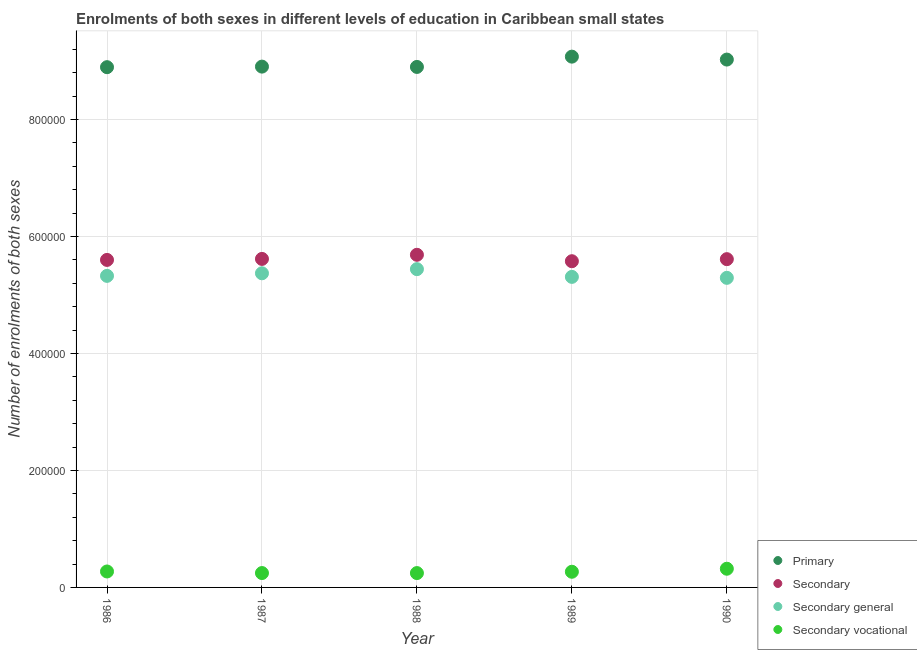What is the number of enrolments in secondary general education in 1990?
Your answer should be compact. 5.29e+05. Across all years, what is the maximum number of enrolments in secondary general education?
Give a very brief answer. 5.44e+05. Across all years, what is the minimum number of enrolments in secondary vocational education?
Ensure brevity in your answer.  2.45e+04. In which year was the number of enrolments in primary education maximum?
Provide a succinct answer. 1989. What is the total number of enrolments in secondary education in the graph?
Offer a very short reply. 2.81e+06. What is the difference between the number of enrolments in primary education in 1986 and that in 1988?
Ensure brevity in your answer.  -413.75. What is the difference between the number of enrolments in secondary vocational education in 1988 and the number of enrolments in primary education in 1990?
Give a very brief answer. -8.78e+05. What is the average number of enrolments in primary education per year?
Your answer should be compact. 8.96e+05. In the year 1987, what is the difference between the number of enrolments in secondary vocational education and number of enrolments in secondary general education?
Ensure brevity in your answer.  -5.13e+05. What is the ratio of the number of enrolments in secondary vocational education in 1986 to that in 1987?
Provide a succinct answer. 1.11. What is the difference between the highest and the second highest number of enrolments in secondary vocational education?
Offer a very short reply. 4682.17. What is the difference between the highest and the lowest number of enrolments in secondary vocational education?
Make the answer very short. 7419.81. Is it the case that in every year, the sum of the number of enrolments in primary education and number of enrolments in secondary education is greater than the sum of number of enrolments in secondary vocational education and number of enrolments in secondary general education?
Make the answer very short. Yes. Is it the case that in every year, the sum of the number of enrolments in primary education and number of enrolments in secondary education is greater than the number of enrolments in secondary general education?
Provide a succinct answer. Yes. Is the number of enrolments in secondary general education strictly greater than the number of enrolments in primary education over the years?
Your answer should be compact. No. Is the number of enrolments in primary education strictly less than the number of enrolments in secondary vocational education over the years?
Ensure brevity in your answer.  No. How many years are there in the graph?
Make the answer very short. 5. Does the graph contain any zero values?
Keep it short and to the point. No. How many legend labels are there?
Keep it short and to the point. 4. What is the title of the graph?
Your answer should be compact. Enrolments of both sexes in different levels of education in Caribbean small states. What is the label or title of the X-axis?
Make the answer very short. Year. What is the label or title of the Y-axis?
Provide a short and direct response. Number of enrolments of both sexes. What is the Number of enrolments of both sexes of Primary in 1986?
Offer a very short reply. 8.89e+05. What is the Number of enrolments of both sexes in Secondary in 1986?
Give a very brief answer. 5.60e+05. What is the Number of enrolments of both sexes in Secondary general in 1986?
Keep it short and to the point. 5.33e+05. What is the Number of enrolments of both sexes of Secondary vocational in 1986?
Provide a succinct answer. 2.73e+04. What is the Number of enrolments of both sexes in Primary in 1987?
Your answer should be very brief. 8.90e+05. What is the Number of enrolments of both sexes of Secondary in 1987?
Give a very brief answer. 5.62e+05. What is the Number of enrolments of both sexes in Secondary general in 1987?
Provide a succinct answer. 5.37e+05. What is the Number of enrolments of both sexes in Secondary vocational in 1987?
Offer a very short reply. 2.46e+04. What is the Number of enrolments of both sexes of Primary in 1988?
Your response must be concise. 8.90e+05. What is the Number of enrolments of both sexes of Secondary in 1988?
Provide a succinct answer. 5.69e+05. What is the Number of enrolments of both sexes in Secondary general in 1988?
Offer a terse response. 5.44e+05. What is the Number of enrolments of both sexes of Secondary vocational in 1988?
Provide a short and direct response. 2.45e+04. What is the Number of enrolments of both sexes in Primary in 1989?
Make the answer very short. 9.07e+05. What is the Number of enrolments of both sexes of Secondary in 1989?
Keep it short and to the point. 5.58e+05. What is the Number of enrolments of both sexes of Secondary general in 1989?
Provide a succinct answer. 5.31e+05. What is the Number of enrolments of both sexes of Secondary vocational in 1989?
Your response must be concise. 2.68e+04. What is the Number of enrolments of both sexes in Primary in 1990?
Provide a short and direct response. 9.02e+05. What is the Number of enrolments of both sexes in Secondary in 1990?
Provide a succinct answer. 5.61e+05. What is the Number of enrolments of both sexes in Secondary general in 1990?
Offer a terse response. 5.29e+05. What is the Number of enrolments of both sexes of Secondary vocational in 1990?
Your answer should be compact. 3.20e+04. Across all years, what is the maximum Number of enrolments of both sexes in Primary?
Offer a very short reply. 9.07e+05. Across all years, what is the maximum Number of enrolments of both sexes of Secondary?
Give a very brief answer. 5.69e+05. Across all years, what is the maximum Number of enrolments of both sexes in Secondary general?
Make the answer very short. 5.44e+05. Across all years, what is the maximum Number of enrolments of both sexes in Secondary vocational?
Make the answer very short. 3.20e+04. Across all years, what is the minimum Number of enrolments of both sexes of Primary?
Keep it short and to the point. 8.89e+05. Across all years, what is the minimum Number of enrolments of both sexes in Secondary?
Give a very brief answer. 5.58e+05. Across all years, what is the minimum Number of enrolments of both sexes in Secondary general?
Offer a very short reply. 5.29e+05. Across all years, what is the minimum Number of enrolments of both sexes of Secondary vocational?
Provide a succinct answer. 2.45e+04. What is the total Number of enrolments of both sexes in Primary in the graph?
Keep it short and to the point. 4.48e+06. What is the total Number of enrolments of both sexes in Secondary in the graph?
Ensure brevity in your answer.  2.81e+06. What is the total Number of enrolments of both sexes in Secondary general in the graph?
Keep it short and to the point. 2.67e+06. What is the total Number of enrolments of both sexes in Secondary vocational in the graph?
Your response must be concise. 1.35e+05. What is the difference between the Number of enrolments of both sexes in Primary in 1986 and that in 1987?
Keep it short and to the point. -958.44. What is the difference between the Number of enrolments of both sexes of Secondary in 1986 and that in 1987?
Make the answer very short. -1705.69. What is the difference between the Number of enrolments of both sexes of Secondary general in 1986 and that in 1987?
Offer a terse response. -4404.25. What is the difference between the Number of enrolments of both sexes in Secondary vocational in 1986 and that in 1987?
Offer a terse response. 2698.62. What is the difference between the Number of enrolments of both sexes of Primary in 1986 and that in 1988?
Your response must be concise. -413.75. What is the difference between the Number of enrolments of both sexes in Secondary in 1986 and that in 1988?
Make the answer very short. -8743. What is the difference between the Number of enrolments of both sexes in Secondary general in 1986 and that in 1988?
Offer a terse response. -1.15e+04. What is the difference between the Number of enrolments of both sexes of Secondary vocational in 1986 and that in 1988?
Offer a very short reply. 2737.64. What is the difference between the Number of enrolments of both sexes in Primary in 1986 and that in 1989?
Make the answer very short. -1.80e+04. What is the difference between the Number of enrolments of both sexes of Secondary in 1986 and that in 1989?
Your answer should be very brief. 2220.38. What is the difference between the Number of enrolments of both sexes in Secondary general in 1986 and that in 1989?
Your answer should be very brief. 1734.56. What is the difference between the Number of enrolments of both sexes in Secondary vocational in 1986 and that in 1989?
Offer a terse response. 485.85. What is the difference between the Number of enrolments of both sexes of Primary in 1986 and that in 1990?
Offer a very short reply. -1.30e+04. What is the difference between the Number of enrolments of both sexes of Secondary in 1986 and that in 1990?
Give a very brief answer. -1305.38. What is the difference between the Number of enrolments of both sexes of Secondary general in 1986 and that in 1990?
Your answer should be very brief. 3376.81. What is the difference between the Number of enrolments of both sexes in Secondary vocational in 1986 and that in 1990?
Make the answer very short. -4682.17. What is the difference between the Number of enrolments of both sexes of Primary in 1987 and that in 1988?
Provide a short and direct response. 544.69. What is the difference between the Number of enrolments of both sexes in Secondary in 1987 and that in 1988?
Offer a very short reply. -7037.31. What is the difference between the Number of enrolments of both sexes of Secondary general in 1987 and that in 1988?
Keep it short and to the point. -7076.38. What is the difference between the Number of enrolments of both sexes of Secondary vocational in 1987 and that in 1988?
Your response must be concise. 39.03. What is the difference between the Number of enrolments of both sexes in Primary in 1987 and that in 1989?
Provide a succinct answer. -1.70e+04. What is the difference between the Number of enrolments of both sexes of Secondary in 1987 and that in 1989?
Provide a short and direct response. 3926.06. What is the difference between the Number of enrolments of both sexes of Secondary general in 1987 and that in 1989?
Offer a very short reply. 6138.81. What is the difference between the Number of enrolments of both sexes in Secondary vocational in 1987 and that in 1989?
Keep it short and to the point. -2212.77. What is the difference between the Number of enrolments of both sexes of Primary in 1987 and that in 1990?
Provide a succinct answer. -1.20e+04. What is the difference between the Number of enrolments of both sexes in Secondary in 1987 and that in 1990?
Your answer should be very brief. 400.31. What is the difference between the Number of enrolments of both sexes in Secondary general in 1987 and that in 1990?
Offer a terse response. 7781.06. What is the difference between the Number of enrolments of both sexes of Secondary vocational in 1987 and that in 1990?
Your answer should be compact. -7380.79. What is the difference between the Number of enrolments of both sexes in Primary in 1988 and that in 1989?
Your response must be concise. -1.76e+04. What is the difference between the Number of enrolments of both sexes in Secondary in 1988 and that in 1989?
Provide a short and direct response. 1.10e+04. What is the difference between the Number of enrolments of both sexes of Secondary general in 1988 and that in 1989?
Offer a very short reply. 1.32e+04. What is the difference between the Number of enrolments of both sexes of Secondary vocational in 1988 and that in 1989?
Your answer should be compact. -2251.79. What is the difference between the Number of enrolments of both sexes in Primary in 1988 and that in 1990?
Provide a short and direct response. -1.26e+04. What is the difference between the Number of enrolments of both sexes in Secondary in 1988 and that in 1990?
Make the answer very short. 7437.62. What is the difference between the Number of enrolments of both sexes in Secondary general in 1988 and that in 1990?
Provide a succinct answer. 1.49e+04. What is the difference between the Number of enrolments of both sexes of Secondary vocational in 1988 and that in 1990?
Your response must be concise. -7419.81. What is the difference between the Number of enrolments of both sexes of Primary in 1989 and that in 1990?
Give a very brief answer. 5000.31. What is the difference between the Number of enrolments of both sexes in Secondary in 1989 and that in 1990?
Give a very brief answer. -3525.75. What is the difference between the Number of enrolments of both sexes of Secondary general in 1989 and that in 1990?
Give a very brief answer. 1642.25. What is the difference between the Number of enrolments of both sexes of Secondary vocational in 1989 and that in 1990?
Offer a terse response. -5168.02. What is the difference between the Number of enrolments of both sexes of Primary in 1986 and the Number of enrolments of both sexes of Secondary in 1987?
Ensure brevity in your answer.  3.28e+05. What is the difference between the Number of enrolments of both sexes of Primary in 1986 and the Number of enrolments of both sexes of Secondary general in 1987?
Offer a terse response. 3.52e+05. What is the difference between the Number of enrolments of both sexes of Primary in 1986 and the Number of enrolments of both sexes of Secondary vocational in 1987?
Offer a terse response. 8.65e+05. What is the difference between the Number of enrolments of both sexes in Secondary in 1986 and the Number of enrolments of both sexes in Secondary general in 1987?
Offer a very short reply. 2.29e+04. What is the difference between the Number of enrolments of both sexes of Secondary in 1986 and the Number of enrolments of both sexes of Secondary vocational in 1987?
Your answer should be very brief. 5.35e+05. What is the difference between the Number of enrolments of both sexes in Secondary general in 1986 and the Number of enrolments of both sexes in Secondary vocational in 1987?
Ensure brevity in your answer.  5.08e+05. What is the difference between the Number of enrolments of both sexes in Primary in 1986 and the Number of enrolments of both sexes in Secondary in 1988?
Your response must be concise. 3.21e+05. What is the difference between the Number of enrolments of both sexes in Primary in 1986 and the Number of enrolments of both sexes in Secondary general in 1988?
Provide a short and direct response. 3.45e+05. What is the difference between the Number of enrolments of both sexes in Primary in 1986 and the Number of enrolments of both sexes in Secondary vocational in 1988?
Your answer should be compact. 8.65e+05. What is the difference between the Number of enrolments of both sexes of Secondary in 1986 and the Number of enrolments of both sexes of Secondary general in 1988?
Give a very brief answer. 1.58e+04. What is the difference between the Number of enrolments of both sexes of Secondary in 1986 and the Number of enrolments of both sexes of Secondary vocational in 1988?
Your answer should be very brief. 5.35e+05. What is the difference between the Number of enrolments of both sexes of Secondary general in 1986 and the Number of enrolments of both sexes of Secondary vocational in 1988?
Give a very brief answer. 5.08e+05. What is the difference between the Number of enrolments of both sexes in Primary in 1986 and the Number of enrolments of both sexes in Secondary in 1989?
Your response must be concise. 3.32e+05. What is the difference between the Number of enrolments of both sexes in Primary in 1986 and the Number of enrolments of both sexes in Secondary general in 1989?
Your response must be concise. 3.59e+05. What is the difference between the Number of enrolments of both sexes of Primary in 1986 and the Number of enrolments of both sexes of Secondary vocational in 1989?
Provide a succinct answer. 8.63e+05. What is the difference between the Number of enrolments of both sexes of Secondary in 1986 and the Number of enrolments of both sexes of Secondary general in 1989?
Offer a very short reply. 2.90e+04. What is the difference between the Number of enrolments of both sexes of Secondary in 1986 and the Number of enrolments of both sexes of Secondary vocational in 1989?
Your answer should be very brief. 5.33e+05. What is the difference between the Number of enrolments of both sexes in Secondary general in 1986 and the Number of enrolments of both sexes in Secondary vocational in 1989?
Your answer should be compact. 5.06e+05. What is the difference between the Number of enrolments of both sexes of Primary in 1986 and the Number of enrolments of both sexes of Secondary in 1990?
Keep it short and to the point. 3.28e+05. What is the difference between the Number of enrolments of both sexes of Primary in 1986 and the Number of enrolments of both sexes of Secondary general in 1990?
Provide a short and direct response. 3.60e+05. What is the difference between the Number of enrolments of both sexes of Primary in 1986 and the Number of enrolments of both sexes of Secondary vocational in 1990?
Give a very brief answer. 8.58e+05. What is the difference between the Number of enrolments of both sexes of Secondary in 1986 and the Number of enrolments of both sexes of Secondary general in 1990?
Provide a succinct answer. 3.06e+04. What is the difference between the Number of enrolments of both sexes of Secondary in 1986 and the Number of enrolments of both sexes of Secondary vocational in 1990?
Give a very brief answer. 5.28e+05. What is the difference between the Number of enrolments of both sexes of Secondary general in 1986 and the Number of enrolments of both sexes of Secondary vocational in 1990?
Keep it short and to the point. 5.01e+05. What is the difference between the Number of enrolments of both sexes in Primary in 1987 and the Number of enrolments of both sexes in Secondary in 1988?
Provide a short and direct response. 3.22e+05. What is the difference between the Number of enrolments of both sexes of Primary in 1987 and the Number of enrolments of both sexes of Secondary general in 1988?
Ensure brevity in your answer.  3.46e+05. What is the difference between the Number of enrolments of both sexes of Primary in 1987 and the Number of enrolments of both sexes of Secondary vocational in 1988?
Keep it short and to the point. 8.66e+05. What is the difference between the Number of enrolments of both sexes in Secondary in 1987 and the Number of enrolments of both sexes in Secondary general in 1988?
Your answer should be very brief. 1.75e+04. What is the difference between the Number of enrolments of both sexes in Secondary in 1987 and the Number of enrolments of both sexes in Secondary vocational in 1988?
Your answer should be very brief. 5.37e+05. What is the difference between the Number of enrolments of both sexes of Secondary general in 1987 and the Number of enrolments of both sexes of Secondary vocational in 1988?
Ensure brevity in your answer.  5.13e+05. What is the difference between the Number of enrolments of both sexes of Primary in 1987 and the Number of enrolments of both sexes of Secondary in 1989?
Your response must be concise. 3.33e+05. What is the difference between the Number of enrolments of both sexes of Primary in 1987 and the Number of enrolments of both sexes of Secondary general in 1989?
Provide a succinct answer. 3.59e+05. What is the difference between the Number of enrolments of both sexes of Primary in 1987 and the Number of enrolments of both sexes of Secondary vocational in 1989?
Ensure brevity in your answer.  8.64e+05. What is the difference between the Number of enrolments of both sexes in Secondary in 1987 and the Number of enrolments of both sexes in Secondary general in 1989?
Offer a terse response. 3.07e+04. What is the difference between the Number of enrolments of both sexes of Secondary in 1987 and the Number of enrolments of both sexes of Secondary vocational in 1989?
Your response must be concise. 5.35e+05. What is the difference between the Number of enrolments of both sexes of Secondary general in 1987 and the Number of enrolments of both sexes of Secondary vocational in 1989?
Ensure brevity in your answer.  5.10e+05. What is the difference between the Number of enrolments of both sexes in Primary in 1987 and the Number of enrolments of both sexes in Secondary in 1990?
Your answer should be very brief. 3.29e+05. What is the difference between the Number of enrolments of both sexes of Primary in 1987 and the Number of enrolments of both sexes of Secondary general in 1990?
Provide a short and direct response. 3.61e+05. What is the difference between the Number of enrolments of both sexes in Primary in 1987 and the Number of enrolments of both sexes in Secondary vocational in 1990?
Make the answer very short. 8.58e+05. What is the difference between the Number of enrolments of both sexes of Secondary in 1987 and the Number of enrolments of both sexes of Secondary general in 1990?
Ensure brevity in your answer.  3.24e+04. What is the difference between the Number of enrolments of both sexes of Secondary in 1987 and the Number of enrolments of both sexes of Secondary vocational in 1990?
Ensure brevity in your answer.  5.30e+05. What is the difference between the Number of enrolments of both sexes in Secondary general in 1987 and the Number of enrolments of both sexes in Secondary vocational in 1990?
Make the answer very short. 5.05e+05. What is the difference between the Number of enrolments of both sexes in Primary in 1988 and the Number of enrolments of both sexes in Secondary in 1989?
Offer a terse response. 3.32e+05. What is the difference between the Number of enrolments of both sexes in Primary in 1988 and the Number of enrolments of both sexes in Secondary general in 1989?
Your answer should be very brief. 3.59e+05. What is the difference between the Number of enrolments of both sexes in Primary in 1988 and the Number of enrolments of both sexes in Secondary vocational in 1989?
Give a very brief answer. 8.63e+05. What is the difference between the Number of enrolments of both sexes of Secondary in 1988 and the Number of enrolments of both sexes of Secondary general in 1989?
Your answer should be very brief. 3.77e+04. What is the difference between the Number of enrolments of both sexes in Secondary in 1988 and the Number of enrolments of both sexes in Secondary vocational in 1989?
Provide a succinct answer. 5.42e+05. What is the difference between the Number of enrolments of both sexes in Secondary general in 1988 and the Number of enrolments of both sexes in Secondary vocational in 1989?
Offer a terse response. 5.17e+05. What is the difference between the Number of enrolments of both sexes of Primary in 1988 and the Number of enrolments of both sexes of Secondary in 1990?
Provide a succinct answer. 3.29e+05. What is the difference between the Number of enrolments of both sexes of Primary in 1988 and the Number of enrolments of both sexes of Secondary general in 1990?
Keep it short and to the point. 3.61e+05. What is the difference between the Number of enrolments of both sexes of Primary in 1988 and the Number of enrolments of both sexes of Secondary vocational in 1990?
Your answer should be compact. 8.58e+05. What is the difference between the Number of enrolments of both sexes in Secondary in 1988 and the Number of enrolments of both sexes in Secondary general in 1990?
Your answer should be compact. 3.94e+04. What is the difference between the Number of enrolments of both sexes of Secondary in 1988 and the Number of enrolments of both sexes of Secondary vocational in 1990?
Your response must be concise. 5.37e+05. What is the difference between the Number of enrolments of both sexes of Secondary general in 1988 and the Number of enrolments of both sexes of Secondary vocational in 1990?
Ensure brevity in your answer.  5.12e+05. What is the difference between the Number of enrolments of both sexes in Primary in 1989 and the Number of enrolments of both sexes in Secondary in 1990?
Provide a succinct answer. 3.46e+05. What is the difference between the Number of enrolments of both sexes in Primary in 1989 and the Number of enrolments of both sexes in Secondary general in 1990?
Your answer should be very brief. 3.78e+05. What is the difference between the Number of enrolments of both sexes of Primary in 1989 and the Number of enrolments of both sexes of Secondary vocational in 1990?
Make the answer very short. 8.76e+05. What is the difference between the Number of enrolments of both sexes of Secondary in 1989 and the Number of enrolments of both sexes of Secondary general in 1990?
Make the answer very short. 2.84e+04. What is the difference between the Number of enrolments of both sexes of Secondary in 1989 and the Number of enrolments of both sexes of Secondary vocational in 1990?
Provide a short and direct response. 5.26e+05. What is the difference between the Number of enrolments of both sexes of Secondary general in 1989 and the Number of enrolments of both sexes of Secondary vocational in 1990?
Provide a succinct answer. 4.99e+05. What is the average Number of enrolments of both sexes in Primary per year?
Your answer should be compact. 8.96e+05. What is the average Number of enrolments of both sexes in Secondary per year?
Your response must be concise. 5.62e+05. What is the average Number of enrolments of both sexes of Secondary general per year?
Provide a short and direct response. 5.35e+05. What is the average Number of enrolments of both sexes of Secondary vocational per year?
Offer a very short reply. 2.70e+04. In the year 1986, what is the difference between the Number of enrolments of both sexes of Primary and Number of enrolments of both sexes of Secondary?
Keep it short and to the point. 3.30e+05. In the year 1986, what is the difference between the Number of enrolments of both sexes in Primary and Number of enrolments of both sexes in Secondary general?
Offer a terse response. 3.57e+05. In the year 1986, what is the difference between the Number of enrolments of both sexes in Primary and Number of enrolments of both sexes in Secondary vocational?
Offer a very short reply. 8.62e+05. In the year 1986, what is the difference between the Number of enrolments of both sexes in Secondary and Number of enrolments of both sexes in Secondary general?
Offer a terse response. 2.73e+04. In the year 1986, what is the difference between the Number of enrolments of both sexes of Secondary and Number of enrolments of both sexes of Secondary vocational?
Keep it short and to the point. 5.33e+05. In the year 1986, what is the difference between the Number of enrolments of both sexes of Secondary general and Number of enrolments of both sexes of Secondary vocational?
Give a very brief answer. 5.05e+05. In the year 1987, what is the difference between the Number of enrolments of both sexes of Primary and Number of enrolments of both sexes of Secondary?
Provide a short and direct response. 3.29e+05. In the year 1987, what is the difference between the Number of enrolments of both sexes of Primary and Number of enrolments of both sexes of Secondary general?
Keep it short and to the point. 3.53e+05. In the year 1987, what is the difference between the Number of enrolments of both sexes in Primary and Number of enrolments of both sexes in Secondary vocational?
Offer a terse response. 8.66e+05. In the year 1987, what is the difference between the Number of enrolments of both sexes of Secondary and Number of enrolments of both sexes of Secondary general?
Offer a very short reply. 2.46e+04. In the year 1987, what is the difference between the Number of enrolments of both sexes of Secondary and Number of enrolments of both sexes of Secondary vocational?
Make the answer very short. 5.37e+05. In the year 1987, what is the difference between the Number of enrolments of both sexes in Secondary general and Number of enrolments of both sexes in Secondary vocational?
Offer a terse response. 5.13e+05. In the year 1988, what is the difference between the Number of enrolments of both sexes in Primary and Number of enrolments of both sexes in Secondary?
Your answer should be compact. 3.21e+05. In the year 1988, what is the difference between the Number of enrolments of both sexes in Primary and Number of enrolments of both sexes in Secondary general?
Offer a very short reply. 3.46e+05. In the year 1988, what is the difference between the Number of enrolments of both sexes in Primary and Number of enrolments of both sexes in Secondary vocational?
Give a very brief answer. 8.65e+05. In the year 1988, what is the difference between the Number of enrolments of both sexes of Secondary and Number of enrolments of both sexes of Secondary general?
Provide a short and direct response. 2.45e+04. In the year 1988, what is the difference between the Number of enrolments of both sexes in Secondary and Number of enrolments of both sexes in Secondary vocational?
Your answer should be very brief. 5.44e+05. In the year 1988, what is the difference between the Number of enrolments of both sexes of Secondary general and Number of enrolments of both sexes of Secondary vocational?
Provide a succinct answer. 5.20e+05. In the year 1989, what is the difference between the Number of enrolments of both sexes of Primary and Number of enrolments of both sexes of Secondary?
Offer a very short reply. 3.50e+05. In the year 1989, what is the difference between the Number of enrolments of both sexes in Primary and Number of enrolments of both sexes in Secondary general?
Provide a succinct answer. 3.77e+05. In the year 1989, what is the difference between the Number of enrolments of both sexes of Primary and Number of enrolments of both sexes of Secondary vocational?
Offer a terse response. 8.81e+05. In the year 1989, what is the difference between the Number of enrolments of both sexes of Secondary and Number of enrolments of both sexes of Secondary general?
Make the answer very short. 2.68e+04. In the year 1989, what is the difference between the Number of enrolments of both sexes of Secondary and Number of enrolments of both sexes of Secondary vocational?
Your answer should be very brief. 5.31e+05. In the year 1989, what is the difference between the Number of enrolments of both sexes of Secondary general and Number of enrolments of both sexes of Secondary vocational?
Provide a short and direct response. 5.04e+05. In the year 1990, what is the difference between the Number of enrolments of both sexes in Primary and Number of enrolments of both sexes in Secondary?
Your answer should be very brief. 3.41e+05. In the year 1990, what is the difference between the Number of enrolments of both sexes of Primary and Number of enrolments of both sexes of Secondary general?
Your answer should be compact. 3.73e+05. In the year 1990, what is the difference between the Number of enrolments of both sexes in Primary and Number of enrolments of both sexes in Secondary vocational?
Keep it short and to the point. 8.71e+05. In the year 1990, what is the difference between the Number of enrolments of both sexes of Secondary and Number of enrolments of both sexes of Secondary general?
Provide a succinct answer. 3.20e+04. In the year 1990, what is the difference between the Number of enrolments of both sexes in Secondary and Number of enrolments of both sexes in Secondary vocational?
Ensure brevity in your answer.  5.29e+05. In the year 1990, what is the difference between the Number of enrolments of both sexes in Secondary general and Number of enrolments of both sexes in Secondary vocational?
Provide a succinct answer. 4.97e+05. What is the ratio of the Number of enrolments of both sexes of Primary in 1986 to that in 1987?
Give a very brief answer. 1. What is the ratio of the Number of enrolments of both sexes of Secondary in 1986 to that in 1987?
Your answer should be compact. 1. What is the ratio of the Number of enrolments of both sexes in Secondary general in 1986 to that in 1987?
Your response must be concise. 0.99. What is the ratio of the Number of enrolments of both sexes of Secondary vocational in 1986 to that in 1987?
Offer a very short reply. 1.11. What is the ratio of the Number of enrolments of both sexes in Primary in 1986 to that in 1988?
Your answer should be compact. 1. What is the ratio of the Number of enrolments of both sexes in Secondary in 1986 to that in 1988?
Keep it short and to the point. 0.98. What is the ratio of the Number of enrolments of both sexes in Secondary general in 1986 to that in 1988?
Your answer should be compact. 0.98. What is the ratio of the Number of enrolments of both sexes in Secondary vocational in 1986 to that in 1988?
Give a very brief answer. 1.11. What is the ratio of the Number of enrolments of both sexes in Primary in 1986 to that in 1989?
Offer a very short reply. 0.98. What is the ratio of the Number of enrolments of both sexes of Secondary in 1986 to that in 1989?
Ensure brevity in your answer.  1. What is the ratio of the Number of enrolments of both sexes in Secondary general in 1986 to that in 1989?
Provide a succinct answer. 1. What is the ratio of the Number of enrolments of both sexes of Secondary vocational in 1986 to that in 1989?
Offer a terse response. 1.02. What is the ratio of the Number of enrolments of both sexes in Primary in 1986 to that in 1990?
Your response must be concise. 0.99. What is the ratio of the Number of enrolments of both sexes in Secondary in 1986 to that in 1990?
Make the answer very short. 1. What is the ratio of the Number of enrolments of both sexes in Secondary general in 1986 to that in 1990?
Provide a succinct answer. 1.01. What is the ratio of the Number of enrolments of both sexes in Secondary vocational in 1986 to that in 1990?
Your answer should be very brief. 0.85. What is the ratio of the Number of enrolments of both sexes in Primary in 1987 to that in 1988?
Keep it short and to the point. 1. What is the ratio of the Number of enrolments of both sexes in Secondary in 1987 to that in 1988?
Ensure brevity in your answer.  0.99. What is the ratio of the Number of enrolments of both sexes of Primary in 1987 to that in 1989?
Provide a short and direct response. 0.98. What is the ratio of the Number of enrolments of both sexes in Secondary in 1987 to that in 1989?
Give a very brief answer. 1.01. What is the ratio of the Number of enrolments of both sexes of Secondary general in 1987 to that in 1989?
Make the answer very short. 1.01. What is the ratio of the Number of enrolments of both sexes in Secondary vocational in 1987 to that in 1989?
Keep it short and to the point. 0.92. What is the ratio of the Number of enrolments of both sexes in Primary in 1987 to that in 1990?
Make the answer very short. 0.99. What is the ratio of the Number of enrolments of both sexes in Secondary general in 1987 to that in 1990?
Your response must be concise. 1.01. What is the ratio of the Number of enrolments of both sexes of Secondary vocational in 1987 to that in 1990?
Ensure brevity in your answer.  0.77. What is the ratio of the Number of enrolments of both sexes of Primary in 1988 to that in 1989?
Make the answer very short. 0.98. What is the ratio of the Number of enrolments of both sexes of Secondary in 1988 to that in 1989?
Your answer should be compact. 1.02. What is the ratio of the Number of enrolments of both sexes of Secondary general in 1988 to that in 1989?
Keep it short and to the point. 1.02. What is the ratio of the Number of enrolments of both sexes in Secondary vocational in 1988 to that in 1989?
Provide a short and direct response. 0.92. What is the ratio of the Number of enrolments of both sexes of Primary in 1988 to that in 1990?
Offer a terse response. 0.99. What is the ratio of the Number of enrolments of both sexes of Secondary in 1988 to that in 1990?
Give a very brief answer. 1.01. What is the ratio of the Number of enrolments of both sexes in Secondary general in 1988 to that in 1990?
Provide a short and direct response. 1.03. What is the ratio of the Number of enrolments of both sexes of Secondary vocational in 1988 to that in 1990?
Ensure brevity in your answer.  0.77. What is the ratio of the Number of enrolments of both sexes in Primary in 1989 to that in 1990?
Provide a short and direct response. 1.01. What is the ratio of the Number of enrolments of both sexes in Secondary general in 1989 to that in 1990?
Make the answer very short. 1. What is the ratio of the Number of enrolments of both sexes in Secondary vocational in 1989 to that in 1990?
Keep it short and to the point. 0.84. What is the difference between the highest and the second highest Number of enrolments of both sexes in Primary?
Your response must be concise. 5000.31. What is the difference between the highest and the second highest Number of enrolments of both sexes in Secondary?
Your answer should be very brief. 7037.31. What is the difference between the highest and the second highest Number of enrolments of both sexes of Secondary general?
Give a very brief answer. 7076.38. What is the difference between the highest and the second highest Number of enrolments of both sexes in Secondary vocational?
Provide a short and direct response. 4682.17. What is the difference between the highest and the lowest Number of enrolments of both sexes in Primary?
Make the answer very short. 1.80e+04. What is the difference between the highest and the lowest Number of enrolments of both sexes of Secondary?
Give a very brief answer. 1.10e+04. What is the difference between the highest and the lowest Number of enrolments of both sexes of Secondary general?
Offer a terse response. 1.49e+04. What is the difference between the highest and the lowest Number of enrolments of both sexes in Secondary vocational?
Ensure brevity in your answer.  7419.81. 